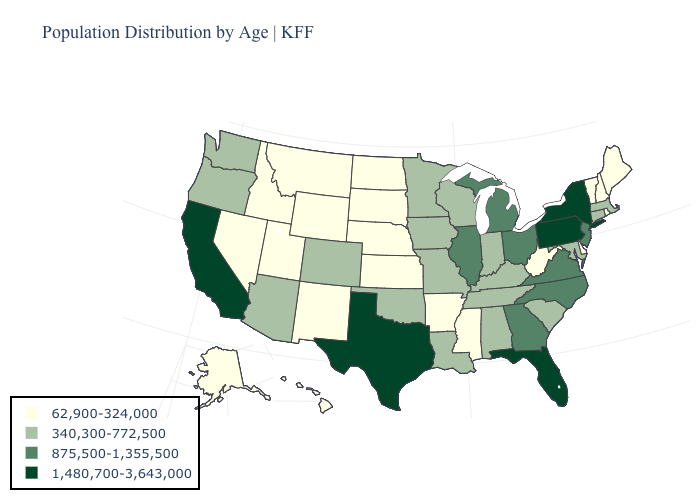What is the value of South Carolina?
Concise answer only. 340,300-772,500. Name the states that have a value in the range 62,900-324,000?
Short answer required. Alaska, Arkansas, Delaware, Hawaii, Idaho, Kansas, Maine, Mississippi, Montana, Nebraska, Nevada, New Hampshire, New Mexico, North Dakota, Rhode Island, South Dakota, Utah, Vermont, West Virginia, Wyoming. Does Pennsylvania have the highest value in the Northeast?
Quick response, please. Yes. What is the highest value in the Northeast ?
Quick response, please. 1,480,700-3,643,000. Among the states that border New Jersey , which have the highest value?
Quick response, please. New York, Pennsylvania. Does New York have the highest value in the USA?
Short answer required. Yes. Does the map have missing data?
Write a very short answer. No. Which states have the highest value in the USA?
Concise answer only. California, Florida, New York, Pennsylvania, Texas. What is the value of North Carolina?
Be succinct. 875,500-1,355,500. Does Colorado have the lowest value in the West?
Give a very brief answer. No. Which states have the lowest value in the Northeast?
Answer briefly. Maine, New Hampshire, Rhode Island, Vermont. Does the map have missing data?
Answer briefly. No. What is the value of Michigan?
Short answer required. 875,500-1,355,500. Among the states that border West Virginia , does Kentucky have the lowest value?
Quick response, please. Yes. Does Nevada have the same value as West Virginia?
Be succinct. Yes. 